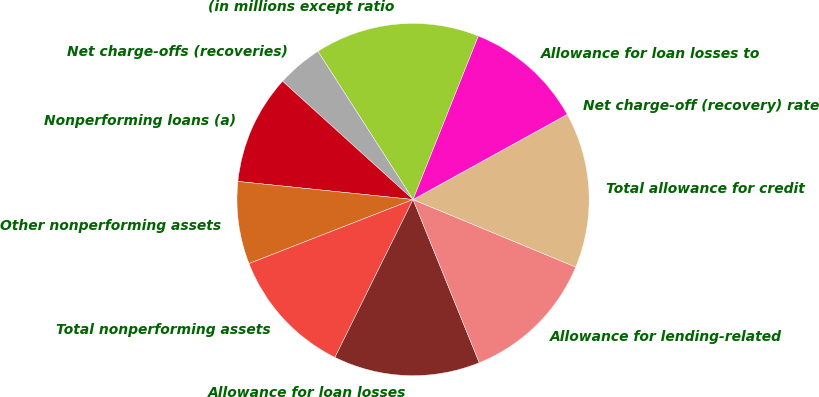Convert chart to OTSL. <chart><loc_0><loc_0><loc_500><loc_500><pie_chart><fcel>(in millions except ratio<fcel>Net charge-offs (recoveries)<fcel>Nonperforming loans (a)<fcel>Other nonperforming assets<fcel>Total nonperforming assets<fcel>Allowance for loan losses<fcel>Allowance for lending-related<fcel>Total allowance for credit<fcel>Net charge-off (recovery) rate<fcel>Allowance for loan losses to<nl><fcel>15.13%<fcel>4.2%<fcel>10.08%<fcel>7.56%<fcel>11.76%<fcel>13.45%<fcel>12.6%<fcel>14.29%<fcel>0.0%<fcel>10.92%<nl></chart> 